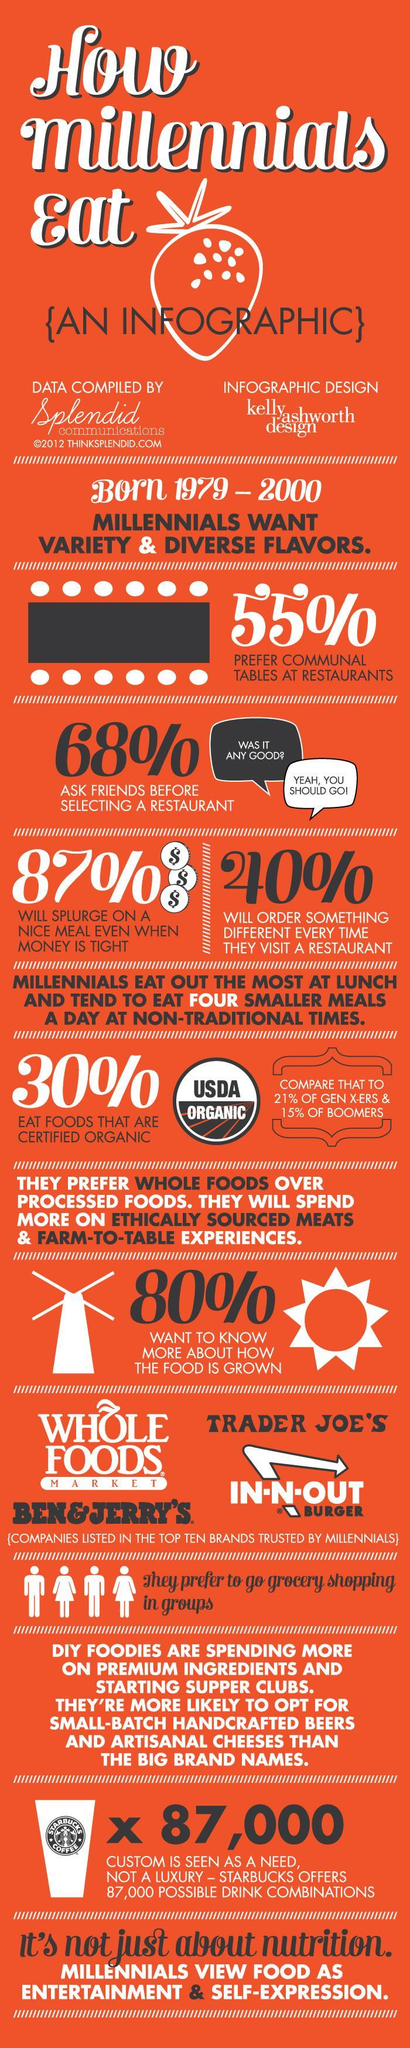Highlight a few significant elements in this photo. According to the provided information, boomers have the lowest percentage of people who prefer organic food among the generations of millennials, generation X, and boomers. 